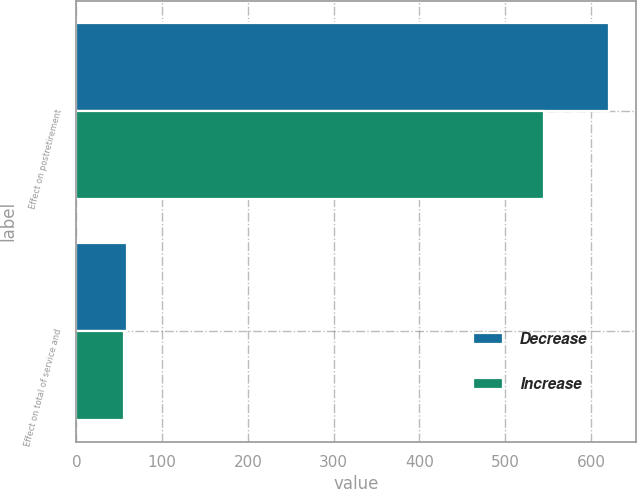Convert chart to OTSL. <chart><loc_0><loc_0><loc_500><loc_500><stacked_bar_chart><ecel><fcel>Effect on postretirement<fcel>Effect on total of service and<nl><fcel>Decrease<fcel>621<fcel>59<nl><fcel>Increase<fcel>545<fcel>55<nl></chart> 